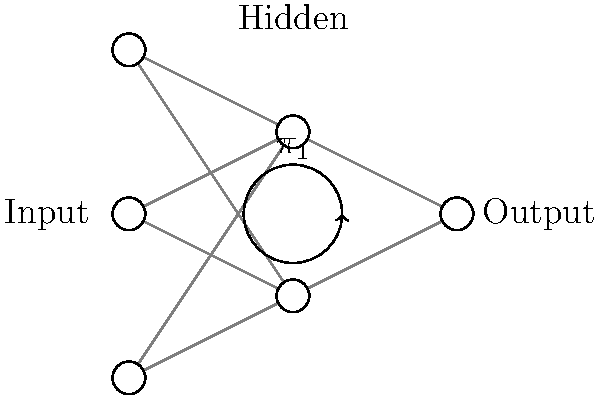Consider the neural network topology shown in the diagram, which represents a simplified model of multilingual processing. The loop in the hidden layer represents a potential homotopy group. If we denote the fundamental group of this network as $\pi_1(X)$, where $X$ is the topological space of the network, what would be the most likely structure of $\pi_1(X)$ given the shown configuration? To determine the structure of $\pi_1(X)$, we need to analyze the topology of the neural network:

1. The network has a feedforward structure with three layers: input, hidden, and output.

2. The key feature is the loop in the hidden layer, which suggests a non-trivial fundamental group.

3. In topological terms, this loop can be seen as a non-contractible cycle in the space of the network.

4. The fundamental group $\pi_1(X)$ captures the equivalence classes of loops in the topological space $X$ up to homotopy.

5. Given that there is one distinct loop shown, and assuming no other hidden topological features, the fundamental group is likely to be isomorphic to the integers under addition, denoted as $\mathbb{Z}$.

6. This is because:
   a) The loop can be traversed any integer number of times.
   b) Positive integers represent counterclockwise rotations.
   c) Negative integers represent clockwise rotations.
   d) Zero represents the identity element (no rotation).

7. The group operation would be the concatenation of loops, which corresponds to addition of integers.

Therefore, the most likely structure for $\pi_1(X)$ is the infinite cyclic group $\mathbb{Z}$.
Answer: $\mathbb{Z}$ (the infinite cyclic group) 